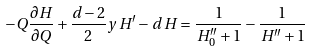Convert formula to latex. <formula><loc_0><loc_0><loc_500><loc_500>- Q \frac { \partial H } { \partial Q } + \frac { d - 2 } { 2 } y \, H ^ { \prime } - d \, H = \frac { 1 } { H _ { 0 } ^ { \prime \prime } + 1 } - \frac { 1 } { H ^ { \prime \prime } + 1 }</formula> 